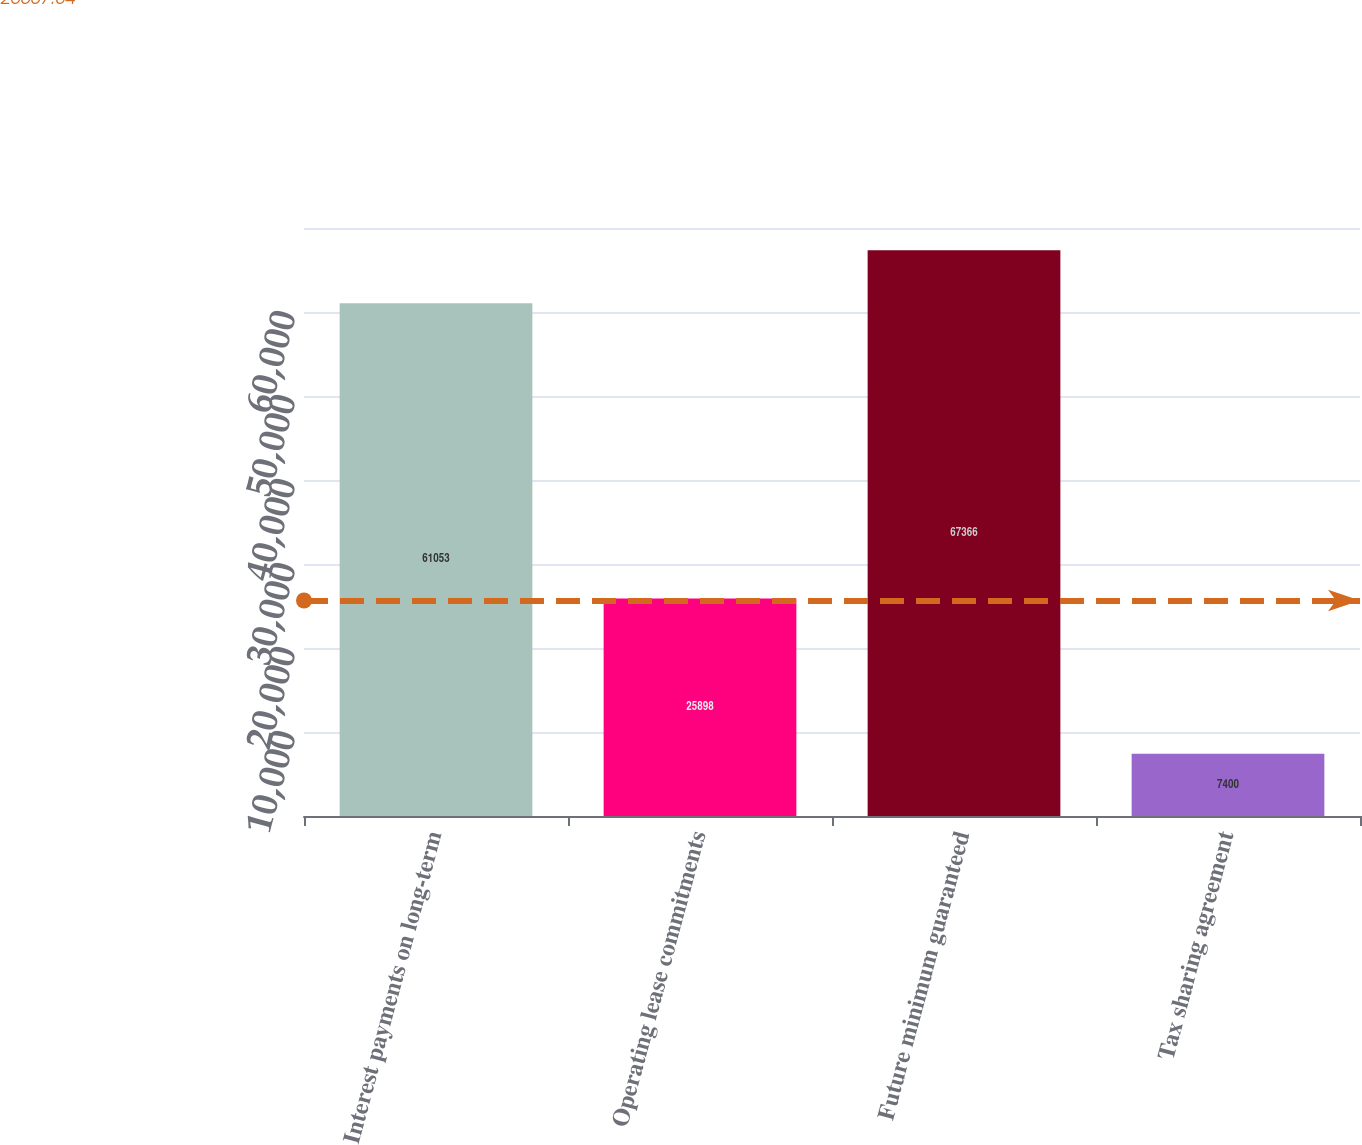Convert chart. <chart><loc_0><loc_0><loc_500><loc_500><bar_chart><fcel>Interest payments on long-term<fcel>Operating lease commitments<fcel>Future minimum guaranteed<fcel>Tax sharing agreement<nl><fcel>61053<fcel>25898<fcel>67366<fcel>7400<nl></chart> 